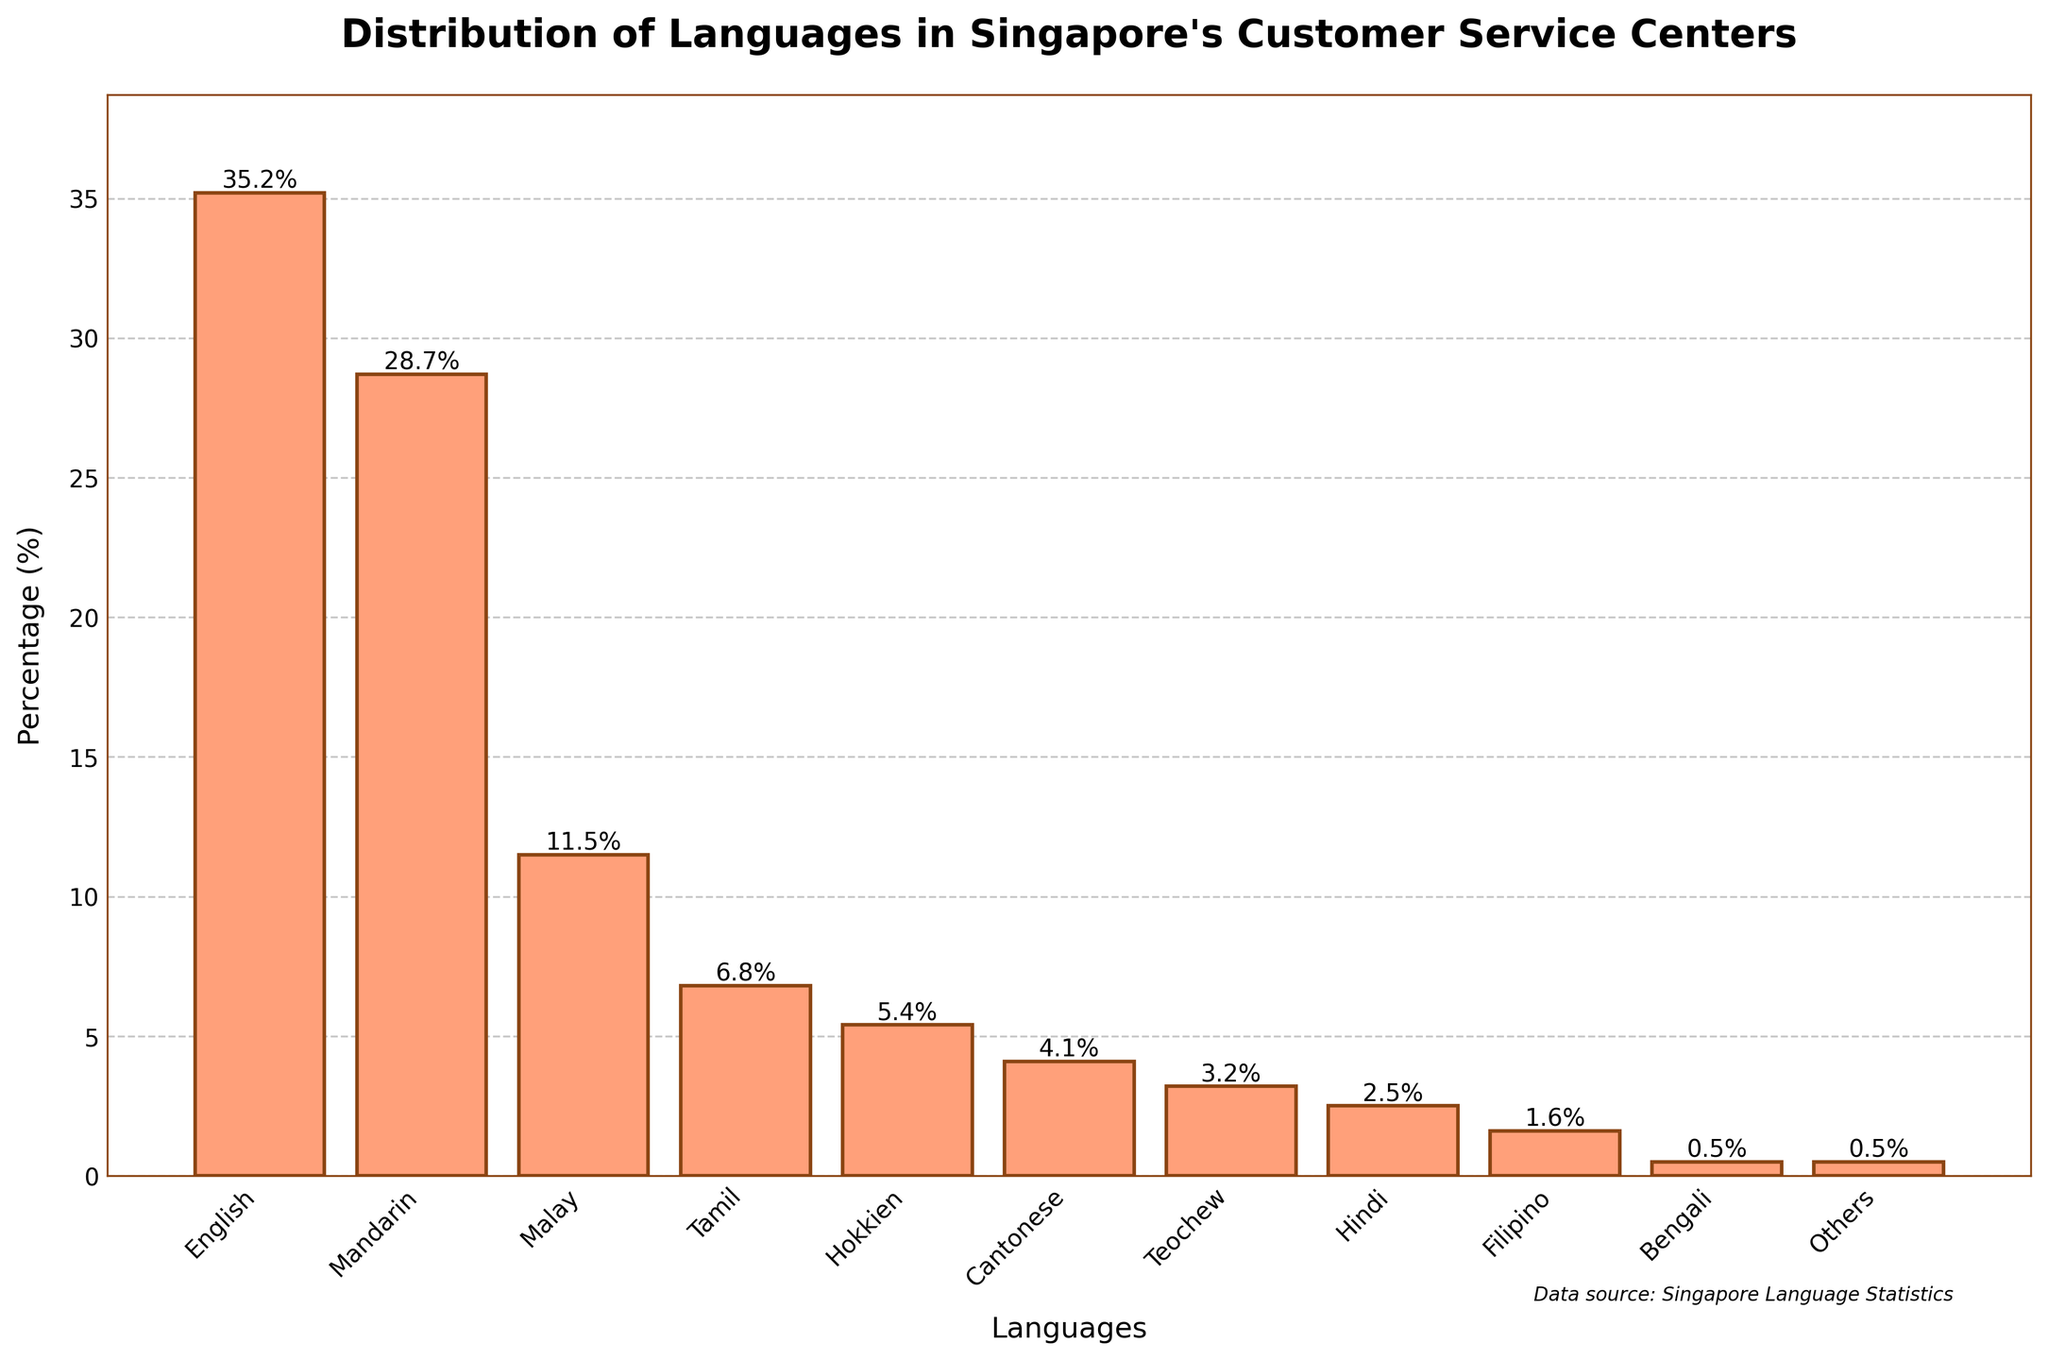Which language is spoken the most in Singapore's customer service centers? The bar with the highest height represents the language spoken the most, which is English at 35.2%.
Answer: English By how much is Mandarin less spoken than English? The percentage for English is 35.2%, and the percentage for Mandarin is 28.7%. The difference is calculated as 35.2 - 28.7 = 6.5%.
Answer: 6.5% Which languages have less than 2% representation in customer service centers? From the bar chart, the languages with less than 2% are Filipino (1.6%) and Bengali (0.5%).
Answer: Filipino and Bengali What is the combined percentage of Malay, Tamil, and Hokkien languages spoken? The percentages for Malay, Tamil, and Hokkien are 11.5%, 6.8%, and 5.4% respectively. Adding them together, 11.5 + 6.8 + 5.4 = 23.7%.
Answer: 23.7% Is Teochew less spoken than Cantonese, and by how much? The percentage for Teochew is 3.2%, and for Cantonese, it is 4.1%. The difference is calculated as 4.1 - 3.2 = 0.9%.
Answer: Yes, by 0.9% What is the average percentage of the top three most spoken languages? The top three most spoken languages are English (35.2%), Mandarin (28.7%), and Malay (11.5%). The average is calculated as (35.2 + 28.7 + 11.5) / 3 = 25.13%.
Answer: 25.13% What is the percentage difference between the least spoken language and Tamil? The least spoken language 'Others' has a percentage of 0.5%, and Tamil has 6.8%. The difference is calculated as 6.8 - 0.5 = 6.3%.
Answer: 6.3% Among the languages spoken more than 5%, which one has the smallest percentage? The languages spoken more than 5% are English, Mandarin, Malay, Tamil, and Hokkien. Among these, Hokkien has the smallest percentage at 5.4%.
Answer: Hokkien 